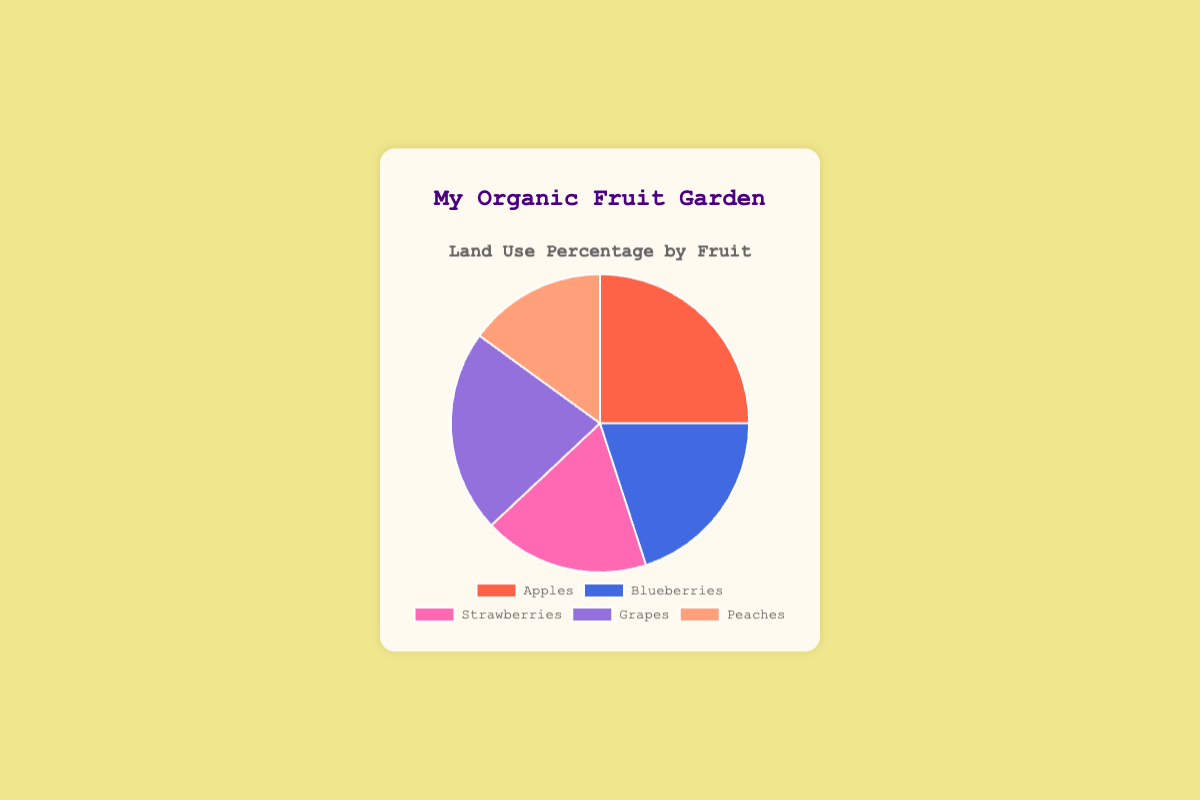Which fruit uses the largest percentage of land in the garden? By looking at the pie chart, find the slice that represents the highest percentage. The label of this slice will tell you which fruit it corresponds to.
Answer: Apples Which two fruits combined use less land than grapes? Grapes use 22% of the land. Look for any two fruits whose combined percentages are less than 22%. Blueberries (20%) and Peaches (15%) have a combined total of 35%, so check another set. Strawberries (18%) and Peaches (15%) have a combined total of 33%. The only pair that works is Peaches and the next lesser value.
Answer: Peaches and Strawberries What is the difference in land use percentage between the fruit that uses the most and the one that uses the least? Identify the largest and smallest percentages from the pie chart. Apples use 25% and Peaches use 15%. Subtract the smallest percentage from the largest. 25% - 15%.
Answer: 10% Are blueberries and strawberries using more land together than apples alone? Sum the land use percentages of Blueberries and Strawberries. Blueberries use 20% and Strawberries use 18%. Together they make 38%. Apples alone use 25% of the land. Compare the combined percentage of Blueberries and Strawberries to the percentage used by Apples.
Answer: Yes What's the average land use percentage of all the fruits? Add all the land use percentages together and divide by the number of fruits. (25% + 20% + 18% + 22% + 15%) = 100%, then divide by 5. 100% / 5.
Answer: 20% Which fruit uses the second-largest percentage of land? First, identify the largest percentage on the pie chart. Apples use 25%. The next largest segment would be Grapes at 22%.
Answer: Grapes Which color represents the land use for strawberries? Locate the slice labeled "Strawberries" and identify its color. According to the provided color scheme, strawberries are represented by the pink color.
Answer: Pink Do peaches use less land than blueberries? Compare the percentages of land use for Peaches and Blueberries. Peaches use 15% of the land, whereas Blueberries use 20%.
Answer: Yes How much larger is the land use for grapes compared to peaches? Subtract the land use percentage of Peaches from that of Grapes. Grapes use 22% and Peaches use 15%. 22% - 15%.
Answer: 7% 